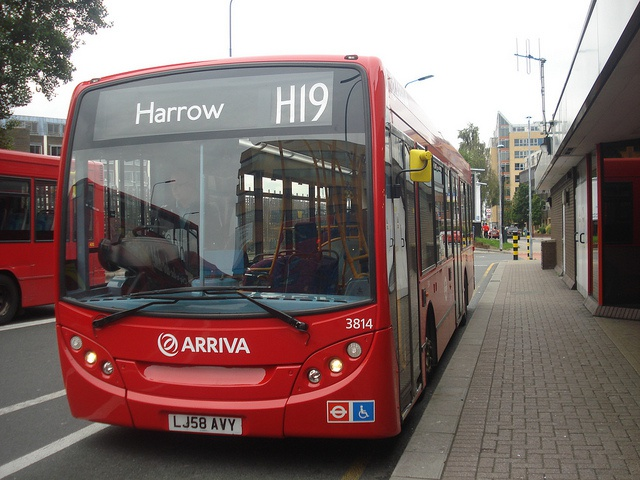Describe the objects in this image and their specific colors. I can see bus in darkgreen, brown, darkgray, black, and gray tones, bus in darkgreen, black, maroon, and gray tones, people in darkgreen, gray, and black tones, and people in darkgreen, black, brown, and red tones in this image. 